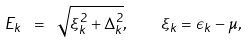<formula> <loc_0><loc_0><loc_500><loc_500>E _ { k } \ = \ \sqrt { \xi _ { k } ^ { 2 } + \Delta _ { k } ^ { 2 } } , \quad \xi _ { k } = \epsilon _ { k } - \mu ,</formula> 